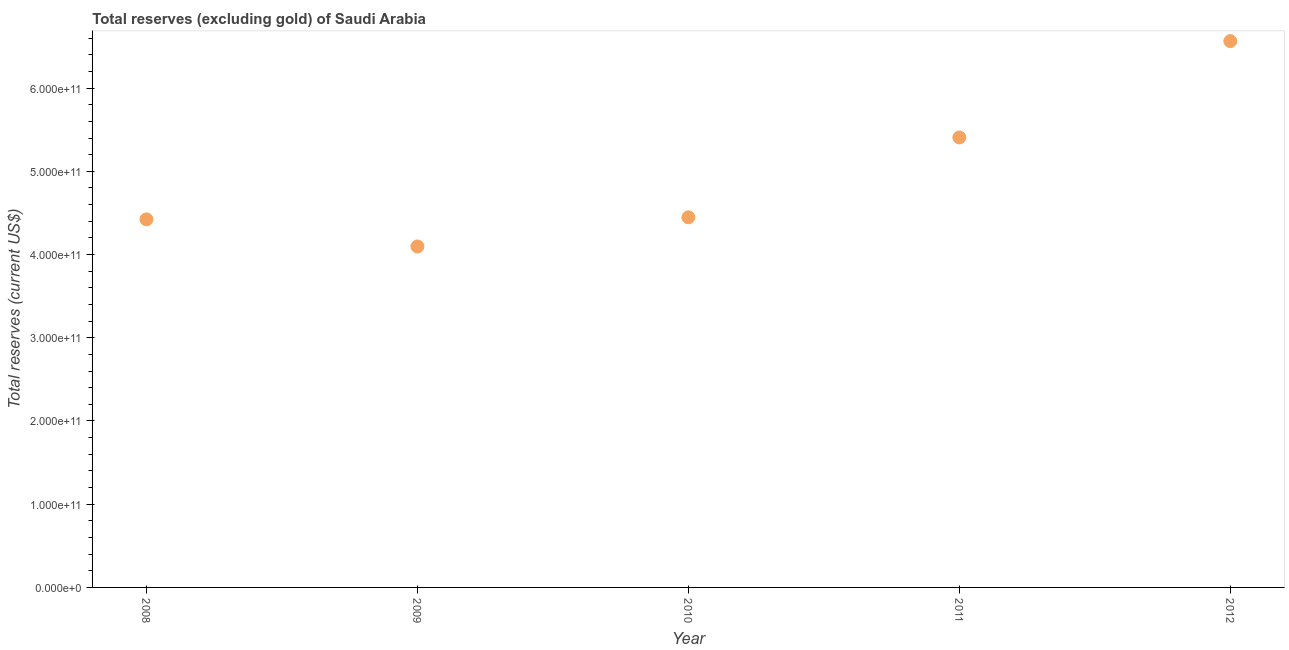What is the total reserves (excluding gold) in 2010?
Your answer should be compact. 4.45e+11. Across all years, what is the maximum total reserves (excluding gold)?
Your answer should be compact. 6.56e+11. Across all years, what is the minimum total reserves (excluding gold)?
Provide a short and direct response. 4.10e+11. In which year was the total reserves (excluding gold) maximum?
Provide a short and direct response. 2012. In which year was the total reserves (excluding gold) minimum?
Your response must be concise. 2009. What is the sum of the total reserves (excluding gold)?
Give a very brief answer. 2.49e+12. What is the difference between the total reserves (excluding gold) in 2010 and 2011?
Give a very brief answer. -9.60e+1. What is the average total reserves (excluding gold) per year?
Your answer should be compact. 4.99e+11. What is the median total reserves (excluding gold)?
Your response must be concise. 4.45e+11. Do a majority of the years between 2008 and 2011 (inclusive) have total reserves (excluding gold) greater than 80000000000 US$?
Give a very brief answer. Yes. What is the ratio of the total reserves (excluding gold) in 2011 to that in 2012?
Your answer should be compact. 0.82. Is the difference between the total reserves (excluding gold) in 2008 and 2009 greater than the difference between any two years?
Provide a short and direct response. No. What is the difference between the highest and the second highest total reserves (excluding gold)?
Provide a succinct answer. 1.16e+11. Is the sum of the total reserves (excluding gold) in 2008 and 2009 greater than the maximum total reserves (excluding gold) across all years?
Provide a succinct answer. Yes. What is the difference between the highest and the lowest total reserves (excluding gold)?
Your answer should be very brief. 2.47e+11. How many years are there in the graph?
Your answer should be compact. 5. What is the difference between two consecutive major ticks on the Y-axis?
Make the answer very short. 1.00e+11. Are the values on the major ticks of Y-axis written in scientific E-notation?
Ensure brevity in your answer.  Yes. Does the graph contain any zero values?
Your answer should be compact. No. Does the graph contain grids?
Offer a very short reply. No. What is the title of the graph?
Your response must be concise. Total reserves (excluding gold) of Saudi Arabia. What is the label or title of the Y-axis?
Provide a short and direct response. Total reserves (current US$). What is the Total reserves (current US$) in 2008?
Offer a very short reply. 4.42e+11. What is the Total reserves (current US$) in 2009?
Your answer should be very brief. 4.10e+11. What is the Total reserves (current US$) in 2010?
Your answer should be compact. 4.45e+11. What is the Total reserves (current US$) in 2011?
Your answer should be compact. 5.41e+11. What is the Total reserves (current US$) in 2012?
Keep it short and to the point. 6.56e+11. What is the difference between the Total reserves (current US$) in 2008 and 2009?
Ensure brevity in your answer.  3.26e+1. What is the difference between the Total reserves (current US$) in 2008 and 2010?
Offer a terse response. -2.47e+09. What is the difference between the Total reserves (current US$) in 2008 and 2011?
Offer a very short reply. -9.84e+1. What is the difference between the Total reserves (current US$) in 2008 and 2012?
Your answer should be very brief. -2.14e+11. What is the difference between the Total reserves (current US$) in 2009 and 2010?
Offer a terse response. -3.50e+1. What is the difference between the Total reserves (current US$) in 2009 and 2011?
Offer a very short reply. -1.31e+11. What is the difference between the Total reserves (current US$) in 2009 and 2012?
Ensure brevity in your answer.  -2.47e+11. What is the difference between the Total reserves (current US$) in 2010 and 2011?
Provide a succinct answer. -9.60e+1. What is the difference between the Total reserves (current US$) in 2010 and 2012?
Make the answer very short. -2.12e+11. What is the difference between the Total reserves (current US$) in 2011 and 2012?
Make the answer very short. -1.16e+11. What is the ratio of the Total reserves (current US$) in 2008 to that in 2009?
Provide a short and direct response. 1.08. What is the ratio of the Total reserves (current US$) in 2008 to that in 2011?
Make the answer very short. 0.82. What is the ratio of the Total reserves (current US$) in 2008 to that in 2012?
Give a very brief answer. 0.67. What is the ratio of the Total reserves (current US$) in 2009 to that in 2010?
Your answer should be compact. 0.92. What is the ratio of the Total reserves (current US$) in 2009 to that in 2011?
Your answer should be compact. 0.76. What is the ratio of the Total reserves (current US$) in 2009 to that in 2012?
Make the answer very short. 0.62. What is the ratio of the Total reserves (current US$) in 2010 to that in 2011?
Provide a short and direct response. 0.82. What is the ratio of the Total reserves (current US$) in 2010 to that in 2012?
Give a very brief answer. 0.68. What is the ratio of the Total reserves (current US$) in 2011 to that in 2012?
Ensure brevity in your answer.  0.82. 